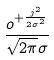Convert formula to latex. <formula><loc_0><loc_0><loc_500><loc_500>\frac { o ^ { + \frac { j ^ { 2 } } { 2 \sigma ^ { 2 } } } } { \sqrt { 2 \pi } \sigma }</formula> 